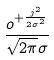Convert formula to latex. <formula><loc_0><loc_0><loc_500><loc_500>\frac { o ^ { + \frac { j ^ { 2 } } { 2 \sigma ^ { 2 } } } } { \sqrt { 2 \pi } \sigma }</formula> 